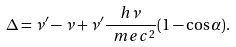Convert formula to latex. <formula><loc_0><loc_0><loc_500><loc_500>\Delta = \nu ^ { \prime } - \nu + \nu ^ { \prime } \frac { h \nu } { \ m e c ^ { 2 } } ( 1 - \cos { \alpha } ) .</formula> 